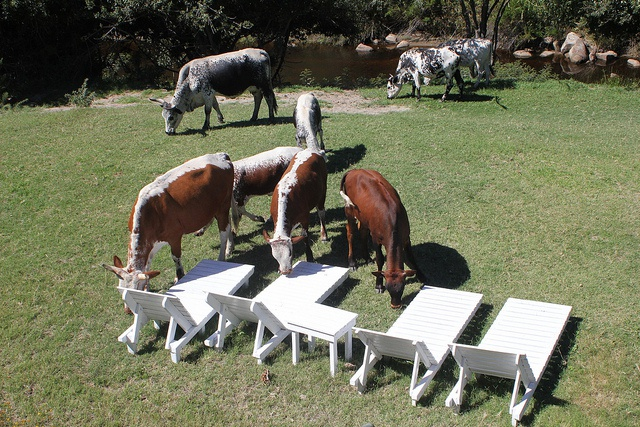Describe the objects in this image and their specific colors. I can see cow in black, maroon, lightgray, and gray tones, chair in black, white, and gray tones, chair in black, white, darkgray, and gray tones, cow in black, maroon, and brown tones, and chair in black, white, darkgray, and gray tones in this image. 